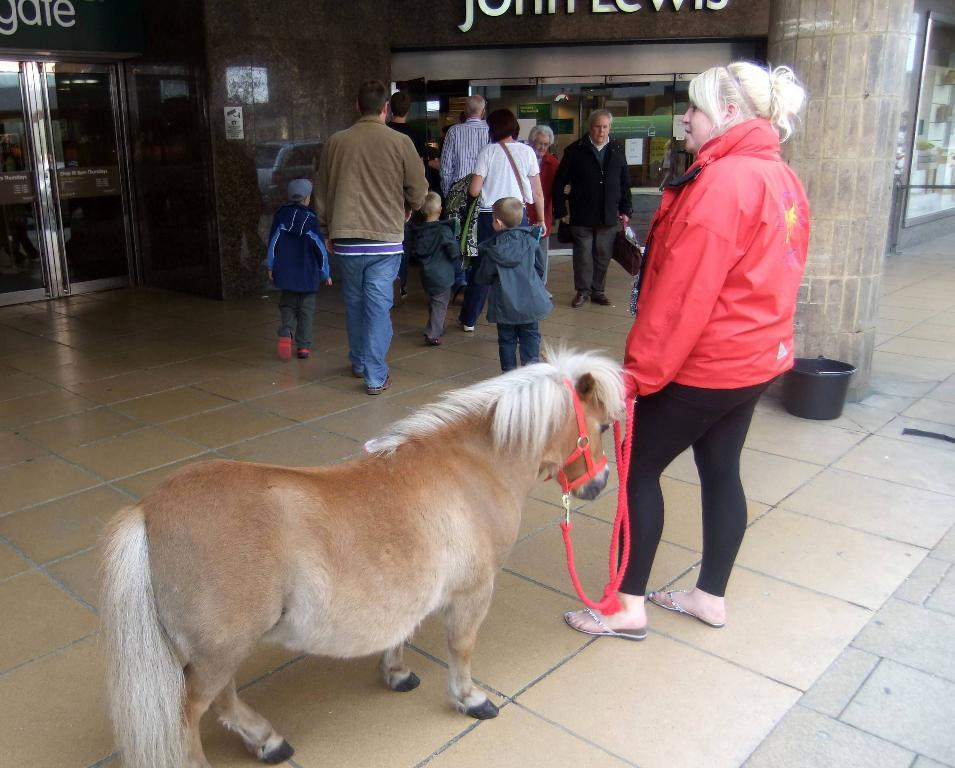What can be seen in the image that people might walk on? There is a path in the image that people might walk on. Can you describe the people in the image? There are people in the image, including a woman holding a red color rope. What is the woman holding in the image? The woman is holding a red color rope that is tied to a small horse. What is written or visible on a surface in the image? There are words written on a wall in the image. Can you see a kite flying in the image? There is no kite visible in the image. Is there a horn attached to the small horse in the image? There is no horn mentioned or visible in the image; the woman is holding a red color rope tied to the small horse. --- 